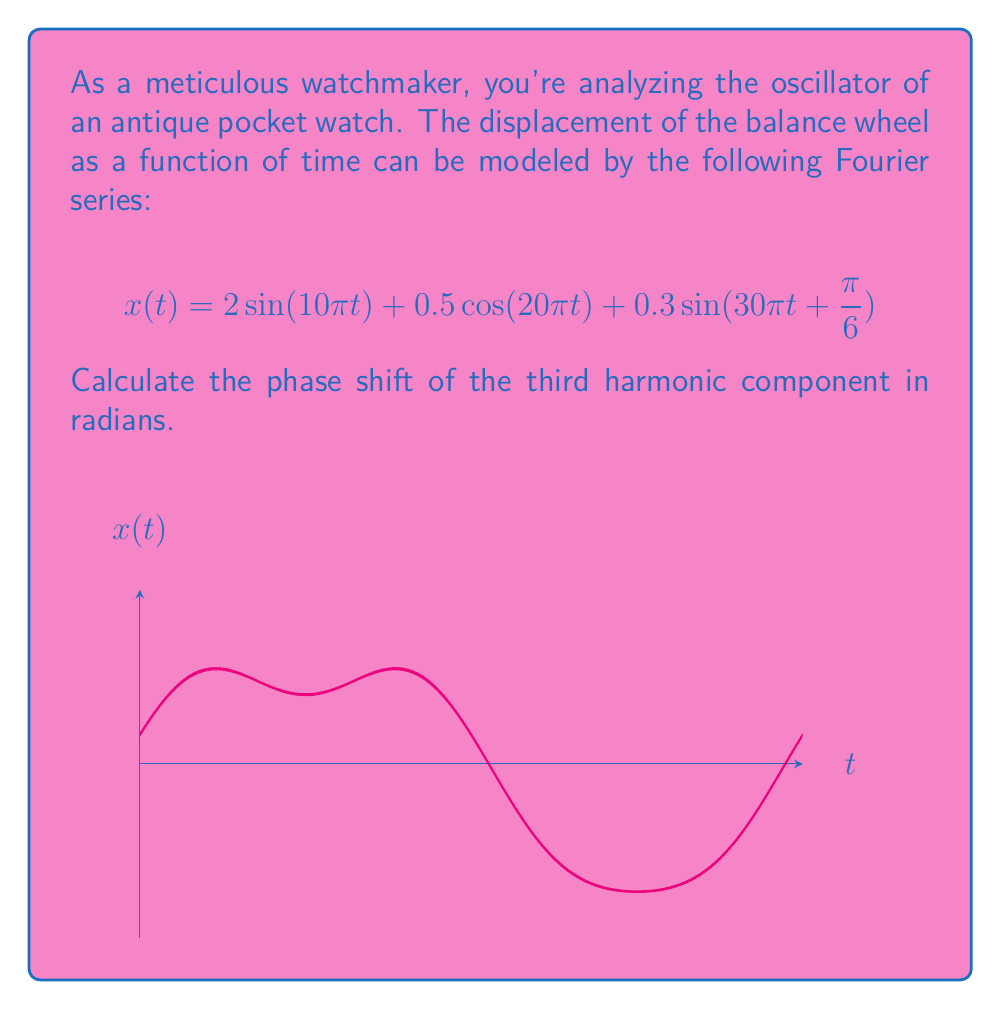Can you solve this math problem? To solve this problem, we need to identify the third harmonic component and its phase shift. Let's break it down step-by-step:

1) The given Fourier series has three terms:
   $$x(t) = 2\sin(10\pi t) + 0.5\cos(20\pi t) + 0.3\sin(30\pi t + \frac{\pi}{6})$$

2) The third harmonic is the term with the highest frequency, which is:
   $$0.3\sin(30\pi t + \frac{\pi}{6})$$

3) The general form of a sinusoidal function is:
   $$A\sin(\omega t + \phi)$$
   where $\phi$ is the phase shift.

4) Comparing our third harmonic to this general form:
   $$0.3\sin(30\pi t + \frac{\pi}{6})$$
   We can see that the phase shift $\phi$ is directly given as $\frac{\pi}{6}$.

5) Therefore, the phase shift of the third harmonic component is $\frac{\pi}{6}$ radians.
Answer: $\frac{\pi}{6}$ radians 